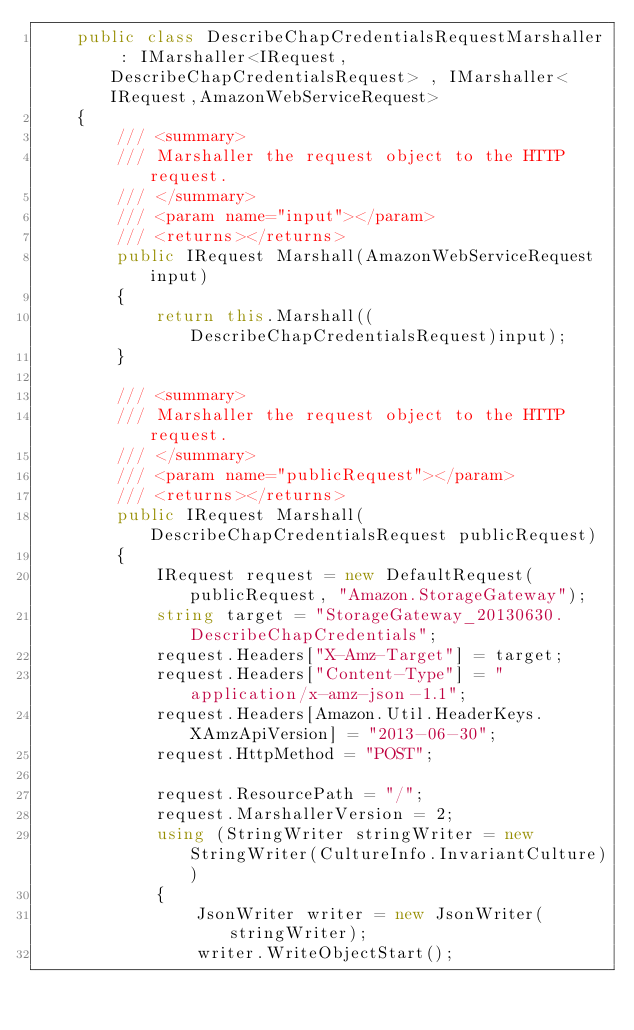<code> <loc_0><loc_0><loc_500><loc_500><_C#_>    public class DescribeChapCredentialsRequestMarshaller : IMarshaller<IRequest, DescribeChapCredentialsRequest> , IMarshaller<IRequest,AmazonWebServiceRequest>
    {
        /// <summary>
        /// Marshaller the request object to the HTTP request.
        /// </summary>  
        /// <param name="input"></param>
        /// <returns></returns>
        public IRequest Marshall(AmazonWebServiceRequest input)
        {
            return this.Marshall((DescribeChapCredentialsRequest)input);
        }

        /// <summary>
        /// Marshaller the request object to the HTTP request.
        /// </summary>  
        /// <param name="publicRequest"></param>
        /// <returns></returns>
        public IRequest Marshall(DescribeChapCredentialsRequest publicRequest)
        {
            IRequest request = new DefaultRequest(publicRequest, "Amazon.StorageGateway");
            string target = "StorageGateway_20130630.DescribeChapCredentials";
            request.Headers["X-Amz-Target"] = target;
            request.Headers["Content-Type"] = "application/x-amz-json-1.1";
            request.Headers[Amazon.Util.HeaderKeys.XAmzApiVersion] = "2013-06-30";            
            request.HttpMethod = "POST";

            request.ResourcePath = "/";
            request.MarshallerVersion = 2;
            using (StringWriter stringWriter = new StringWriter(CultureInfo.InvariantCulture))
            {
                JsonWriter writer = new JsonWriter(stringWriter);
                writer.WriteObjectStart();</code> 